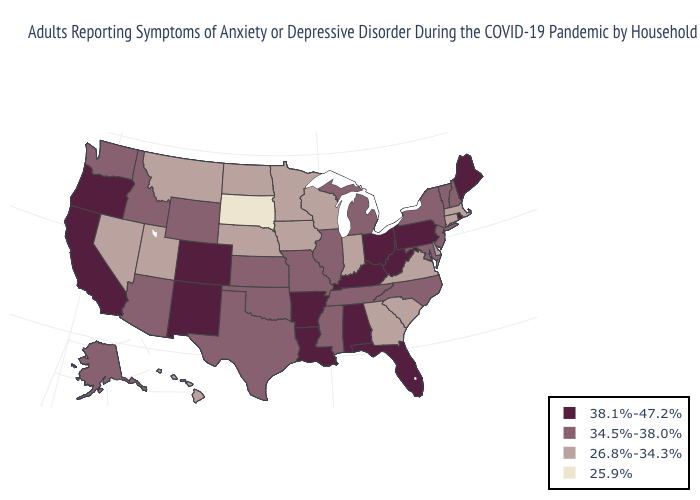What is the value of New Jersey?
Short answer required. 34.5%-38.0%. What is the value of New Hampshire?
Keep it brief. 34.5%-38.0%. What is the lowest value in states that border Georgia?
Give a very brief answer. 26.8%-34.3%. Does Virginia have the same value as Hawaii?
Write a very short answer. Yes. Among the states that border Wyoming , which have the lowest value?
Short answer required. South Dakota. Among the states that border Vermont , does Massachusetts have the lowest value?
Be succinct. Yes. What is the value of Louisiana?
Short answer required. 38.1%-47.2%. Name the states that have a value in the range 38.1%-47.2%?
Be succinct. Alabama, Arkansas, California, Colorado, Florida, Kentucky, Louisiana, Maine, New Mexico, Ohio, Oregon, Pennsylvania, Rhode Island, West Virginia. Does Arizona have the highest value in the West?
Write a very short answer. No. What is the highest value in the South ?
Concise answer only. 38.1%-47.2%. Is the legend a continuous bar?
Quick response, please. No. Name the states that have a value in the range 38.1%-47.2%?
Concise answer only. Alabama, Arkansas, California, Colorado, Florida, Kentucky, Louisiana, Maine, New Mexico, Ohio, Oregon, Pennsylvania, Rhode Island, West Virginia. Does Nevada have the lowest value in the West?
Be succinct. Yes. Does the first symbol in the legend represent the smallest category?
Keep it brief. No. Which states have the lowest value in the USA?
Keep it brief. South Dakota. 